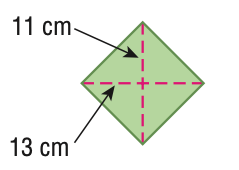Question: Find the area of the figure. Round to the nearest tenth if necessary.
Choices:
A. 48
B. 143
C. 286
D. 572
Answer with the letter. Answer: C 